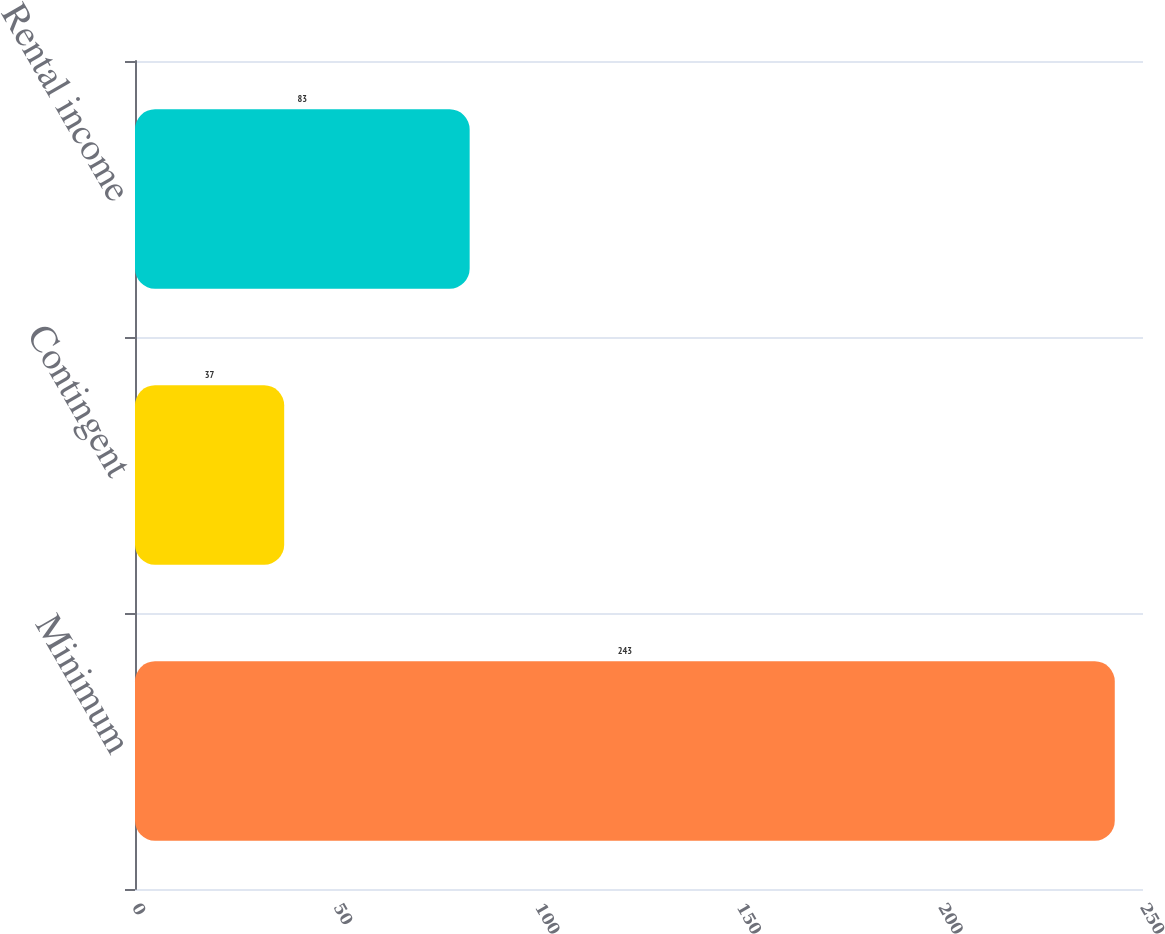Convert chart. <chart><loc_0><loc_0><loc_500><loc_500><bar_chart><fcel>Minimum<fcel>Contingent<fcel>Rental income<nl><fcel>243<fcel>37<fcel>83<nl></chart> 